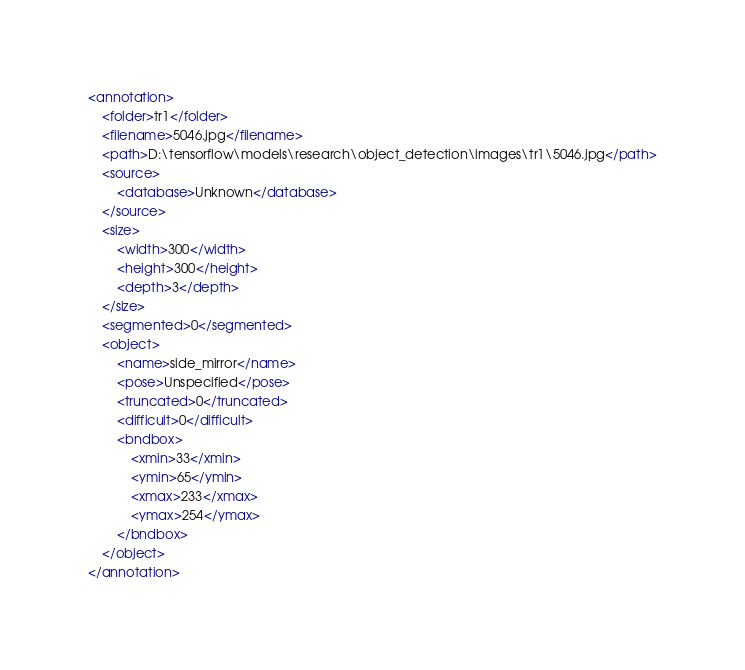Convert code to text. <code><loc_0><loc_0><loc_500><loc_500><_XML_><annotation>
	<folder>tr1</folder>
	<filename>5046.jpg</filename>
	<path>D:\tensorflow\models\research\object_detection\images\tr1\5046.jpg</path>
	<source>
		<database>Unknown</database>
	</source>
	<size>
		<width>300</width>
		<height>300</height>
		<depth>3</depth>
	</size>
	<segmented>0</segmented>
	<object>
		<name>side_mirror</name>
		<pose>Unspecified</pose>
		<truncated>0</truncated>
		<difficult>0</difficult>
		<bndbox>
			<xmin>33</xmin>
			<ymin>65</ymin>
			<xmax>233</xmax>
			<ymax>254</ymax>
		</bndbox>
	</object>
</annotation>
</code> 